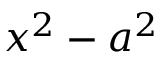<formula> <loc_0><loc_0><loc_500><loc_500>x ^ { 2 } - a ^ { 2 }</formula> 